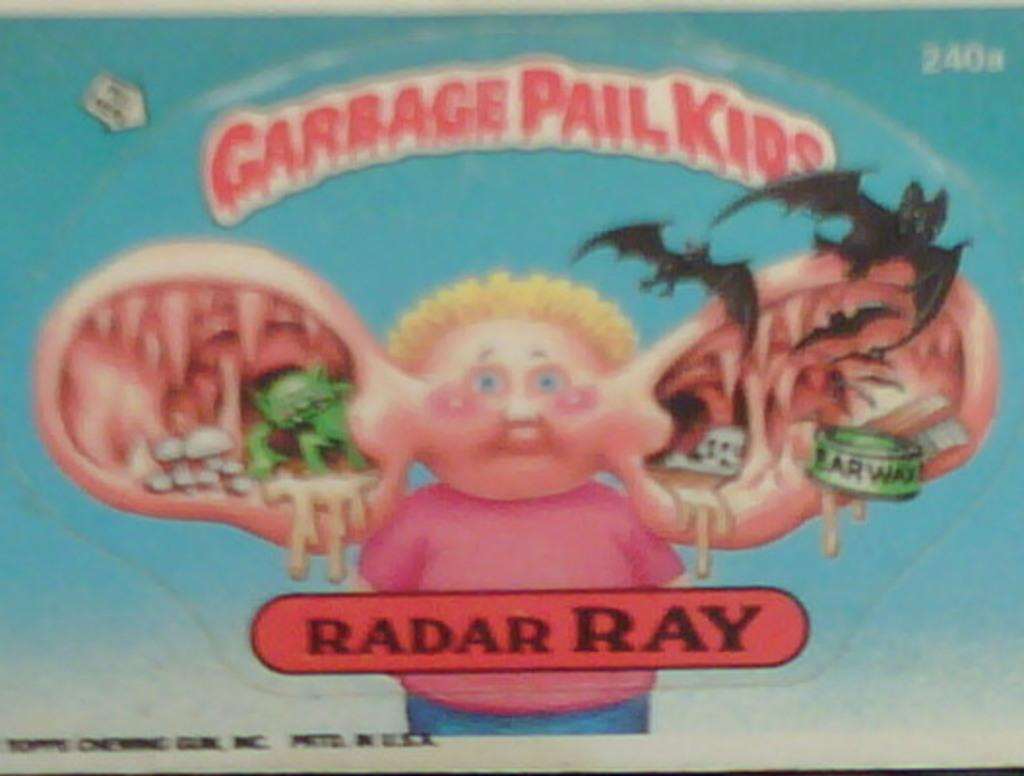What is the main subject in the foreground of the poster? There is a person with big ears in the foreground of the poster. What else can be seen on the poster besides the person with big ears? There is some text on the poster and bats are depicted on the poster. What is the reaction of the mailbox to the person with big ears in the image? There is no mailbox present in the image, so it is not possible to determine its reaction to the person with big ears. 